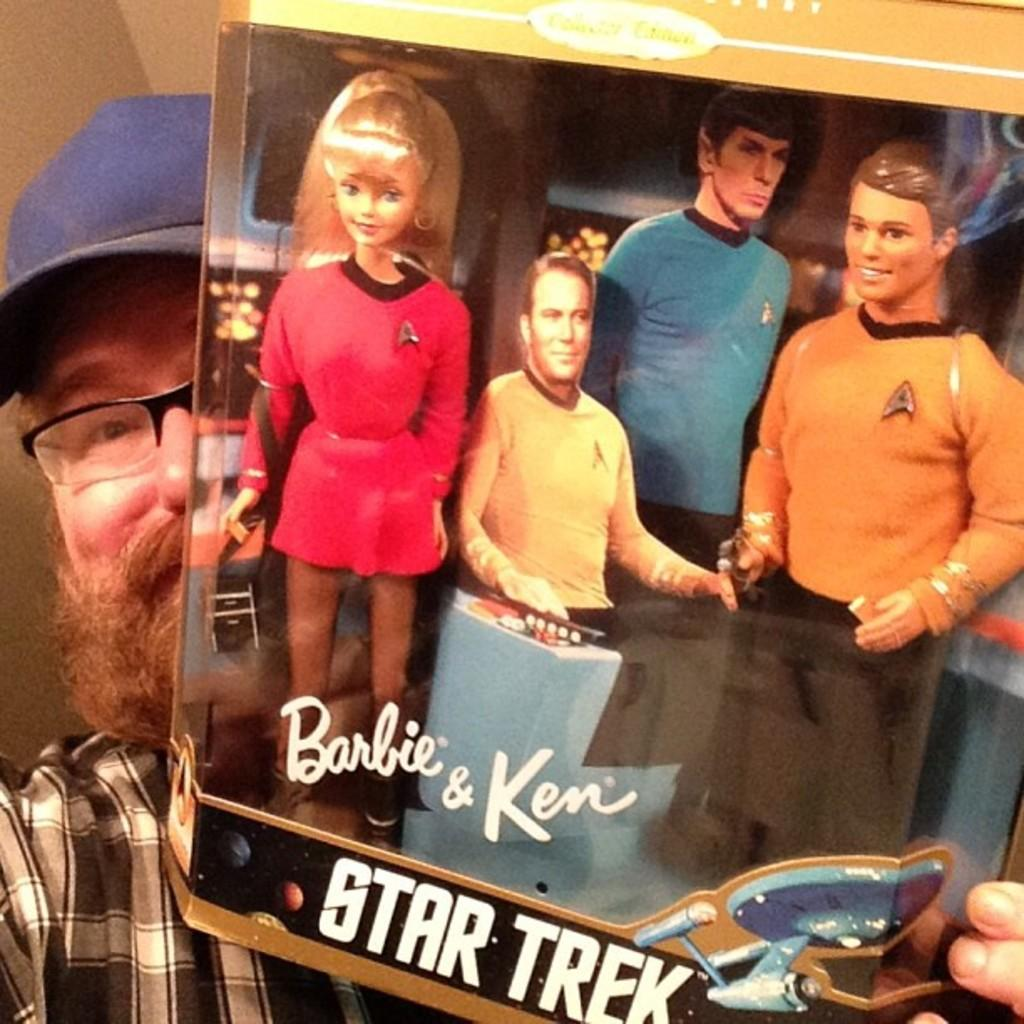What is the main subject of the image? There is a person in the image. What is the person holding in the image? The person is holding a toy. What type of fiction does the person in the image approve of? There is no indication in the image of the person's preferences or opinions about fiction, so it cannot be determined from the picture. 